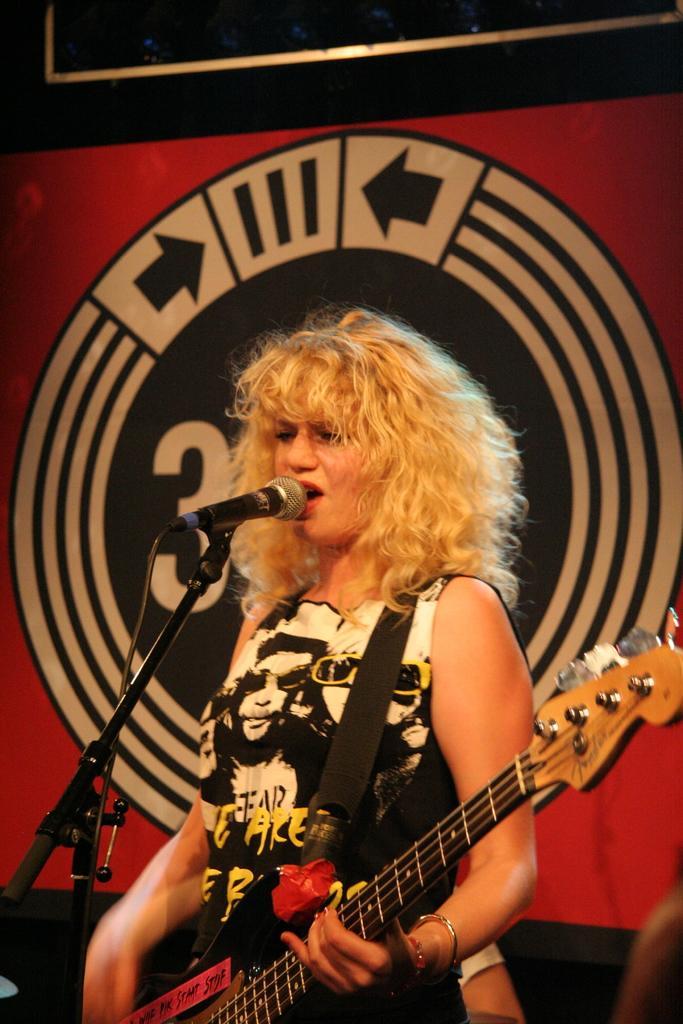How would you summarize this image in a sentence or two? In this image there is a woman who is holding the guitar with her hands has a mic in front of her. The mic is kept on the mic stand. In the background there is a wall on which there is a logo. 